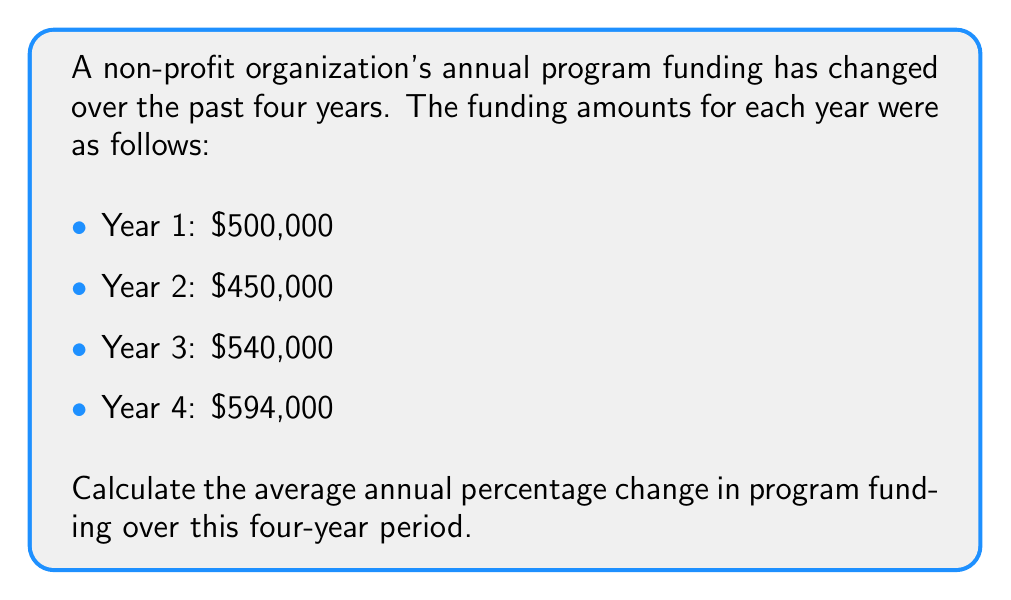Provide a solution to this math problem. To calculate the average annual percentage change, we'll follow these steps:

1. Calculate the percentage change for each year:

Year 1 to Year 2:
$\frac{450,000 - 500,000}{500,000} \times 100\% = -10\%$

Year 2 to Year 3:
$\frac{540,000 - 450,000}{450,000} \times 100\% = 20\%$

Year 3 to Year 4:
$\frac{594,000 - 540,000}{540,000} \times 100\% = 10\%$

2. Sum up the percentage changes:
$-10\% + 20\% + 10\% = 20\%$

3. Calculate the average by dividing the sum by the number of changes (3):
$\frac{20\%}{3} = 6.67\%$

Alternatively, we can use the compound annual growth rate (CAGR) formula:

$$CAGR = \left(\frac{Ending Value}{Beginning Value}\right)^{\frac{1}{n}} - 1$$

Where $n$ is the number of years.

$$CAGR = \left(\frac{594,000}{500,000}\right)^{\frac{1}{4}} - 1 = 1.0667 - 1 = 0.0667 = 6.67\%$$

Both methods yield the same result.
Answer: 6.67% 